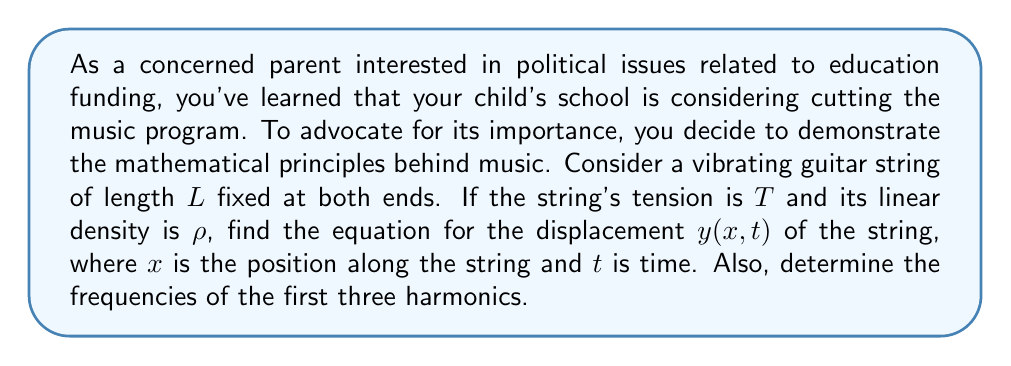What is the answer to this math problem? 1) The wave equation for a vibrating string is:

   $$\frac{\partial^2 y}{\partial t^2} = v^2 \frac{\partial^2 y}{\partial x^2}$$

   where $v = \sqrt{\frac{T}{\rho}}$ is the wave speed.

2) The general solution to this equation is:

   $$y(x,t) = [A \sin(kx) + B \cos(kx)][C \sin(\omega t) + D \cos(\omega t)]$$

3) Applying the boundary conditions $y(0,t) = y(L,t) = 0$:
   - At $x=0$: $B = 0$
   - At $x=L$: $A \sin(kL) = 0$, so $kL = n\pi$, where $n$ is an integer

4) This gives us $k = \frac{n\pi}{L}$ and the solution:

   $$y(x,t) = A \sin(\frac{n\pi x}{L}) [C \sin(\omega t) + D \cos(\omega t)]$$

5) The relationship between $k$ and $\omega$ is $\omega = vk$, so:

   $$\omega = v\frac{n\pi}{L} = \frac{n\pi}{L}\sqrt{\frac{T}{\rho}}$$

6) The frequency $f$ is related to $\omega$ by $\omega = 2\pi f$, so:

   $$f_n = \frac{n}{2L}\sqrt{\frac{T}{\rho}}$$

7) The first three harmonics correspond to $n = 1, 2, 3$:
   - First harmonic (fundamental): $f_1 = \frac{1}{2L}\sqrt{\frac{T}{\rho}}$
   - Second harmonic: $f_2 = \frac{1}{L}\sqrt{\frac{T}{\rho}}$
   - Third harmonic: $f_3 = \frac{3}{2L}\sqrt{\frac{T}{\rho}}$
Answer: $y(x,t) = A \sin(\frac{n\pi x}{L}) [C \sin(\omega t) + D \cos(\omega t)]$, where $\omega = \frac{n\pi}{L}\sqrt{\frac{T}{\rho}}$. First three harmonics: $f_1 = \frac{1}{2L}\sqrt{\frac{T}{\rho}}$, $f_2 = \frac{1}{L}\sqrt{\frac{T}{\rho}}$, $f_3 = \frac{3}{2L}\sqrt{\frac{T}{\rho}}$. 